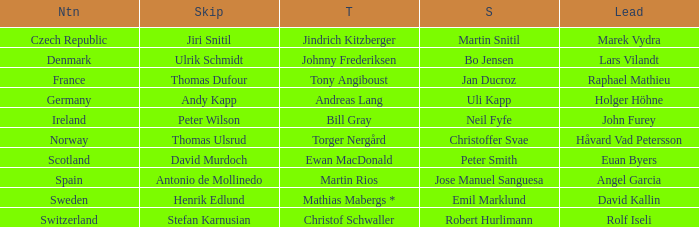In which third did angel garcia lead? Martin Rios. 